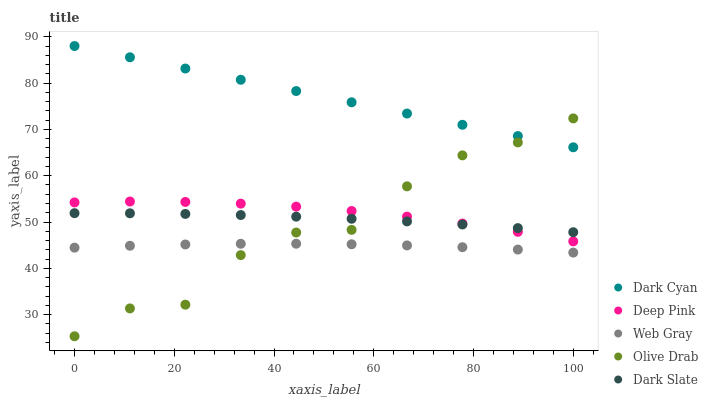Does Web Gray have the minimum area under the curve?
Answer yes or no. Yes. Does Dark Cyan have the maximum area under the curve?
Answer yes or no. Yes. Does Dark Slate have the minimum area under the curve?
Answer yes or no. No. Does Dark Slate have the maximum area under the curve?
Answer yes or no. No. Is Dark Cyan the smoothest?
Answer yes or no. Yes. Is Olive Drab the roughest?
Answer yes or no. Yes. Is Dark Slate the smoothest?
Answer yes or no. No. Is Dark Slate the roughest?
Answer yes or no. No. Does Olive Drab have the lowest value?
Answer yes or no. Yes. Does Dark Slate have the lowest value?
Answer yes or no. No. Does Dark Cyan have the highest value?
Answer yes or no. Yes. Does Dark Slate have the highest value?
Answer yes or no. No. Is Deep Pink less than Dark Cyan?
Answer yes or no. Yes. Is Dark Slate greater than Web Gray?
Answer yes or no. Yes. Does Dark Slate intersect Deep Pink?
Answer yes or no. Yes. Is Dark Slate less than Deep Pink?
Answer yes or no. No. Is Dark Slate greater than Deep Pink?
Answer yes or no. No. Does Deep Pink intersect Dark Cyan?
Answer yes or no. No. 